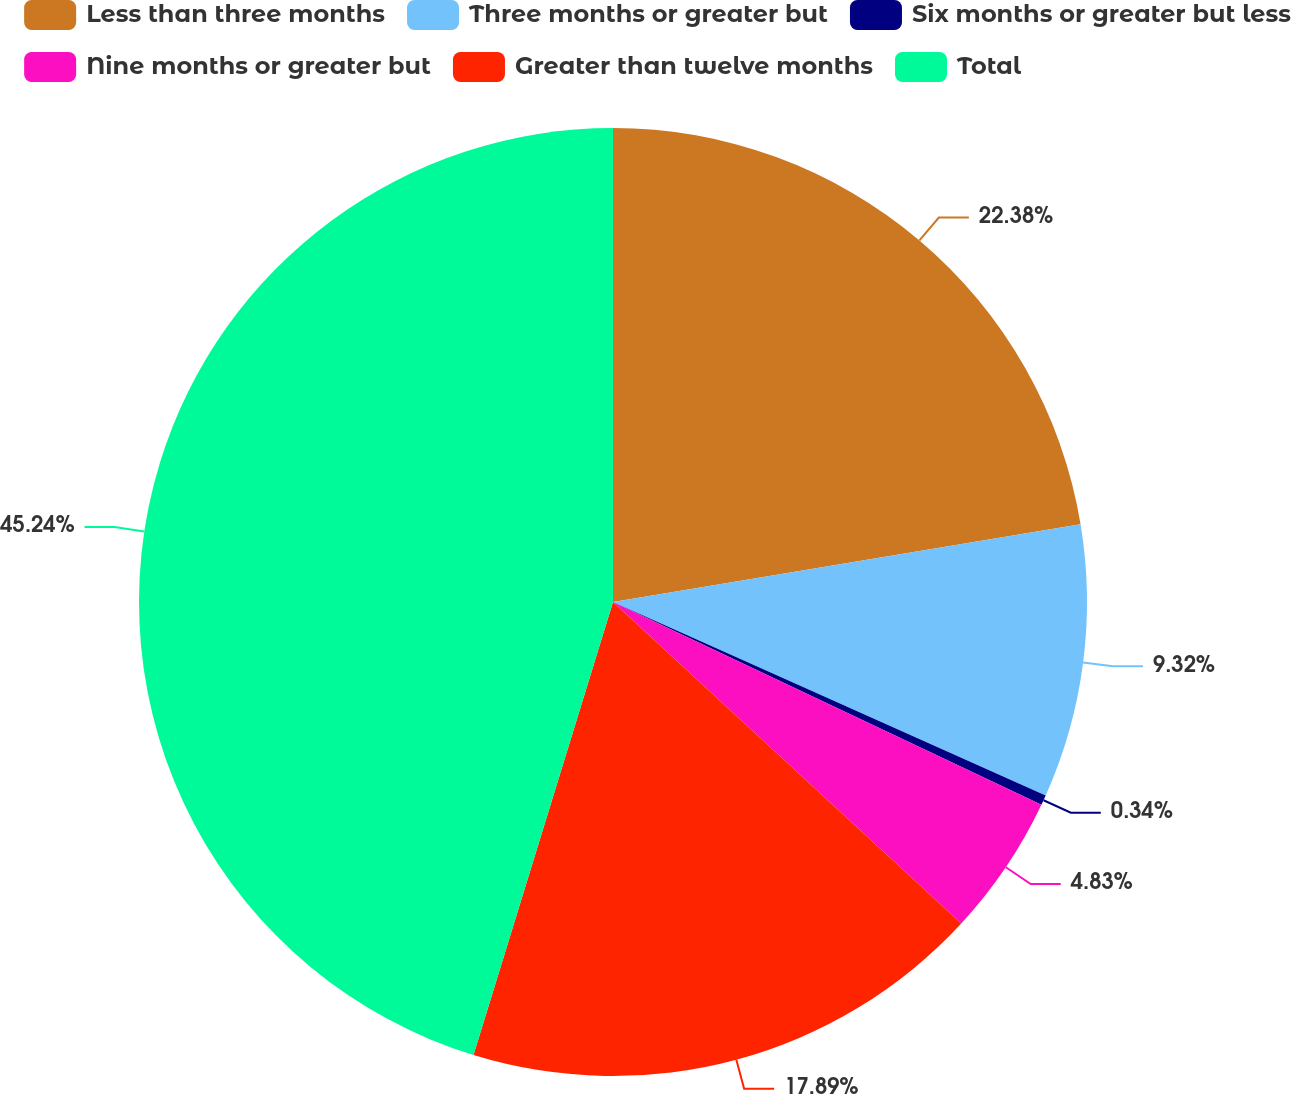<chart> <loc_0><loc_0><loc_500><loc_500><pie_chart><fcel>Less than three months<fcel>Three months or greater but<fcel>Six months or greater but less<fcel>Nine months or greater but<fcel>Greater than twelve months<fcel>Total<nl><fcel>22.38%<fcel>9.32%<fcel>0.34%<fcel>4.83%<fcel>17.89%<fcel>45.25%<nl></chart> 